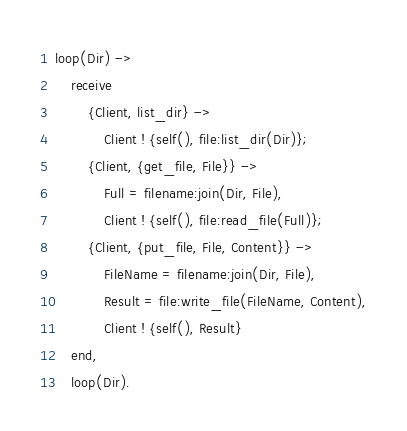Convert code to text. <code><loc_0><loc_0><loc_500><loc_500><_Erlang_>
loop(Dir) ->
    receive
        {Client, list_dir} ->
            Client ! {self(), file:list_dir(Dir)};
        {Client, {get_file, File}} ->
            Full = filename:join(Dir, File),
            Client ! {self(), file:read_file(Full)};
        {Client, {put_file, File, Content}} ->
            FileName = filename:join(Dir, File),
            Result = file:write_file(FileName, Content),
            Client ! {self(), Result}
    end,
    loop(Dir).
</code> 